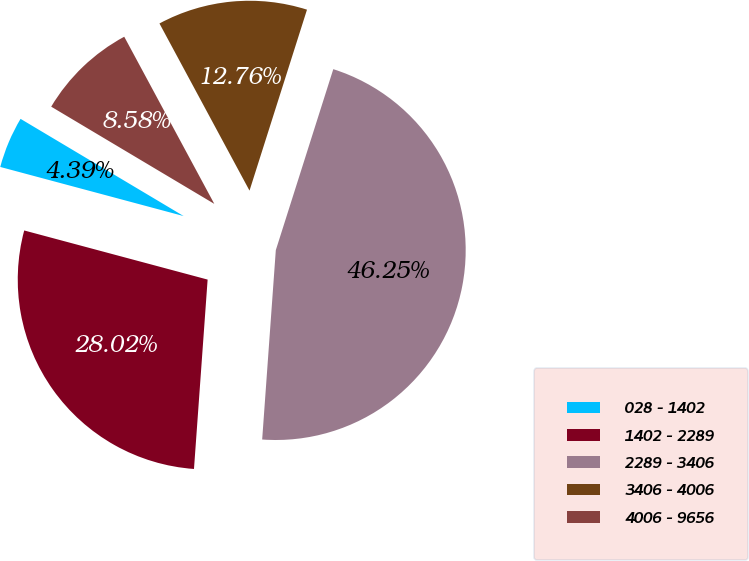Convert chart to OTSL. <chart><loc_0><loc_0><loc_500><loc_500><pie_chart><fcel>028 - 1402<fcel>1402 - 2289<fcel>2289 - 3406<fcel>3406 - 4006<fcel>4006 - 9656<nl><fcel>4.39%<fcel>28.02%<fcel>46.25%<fcel>12.76%<fcel>8.58%<nl></chart> 